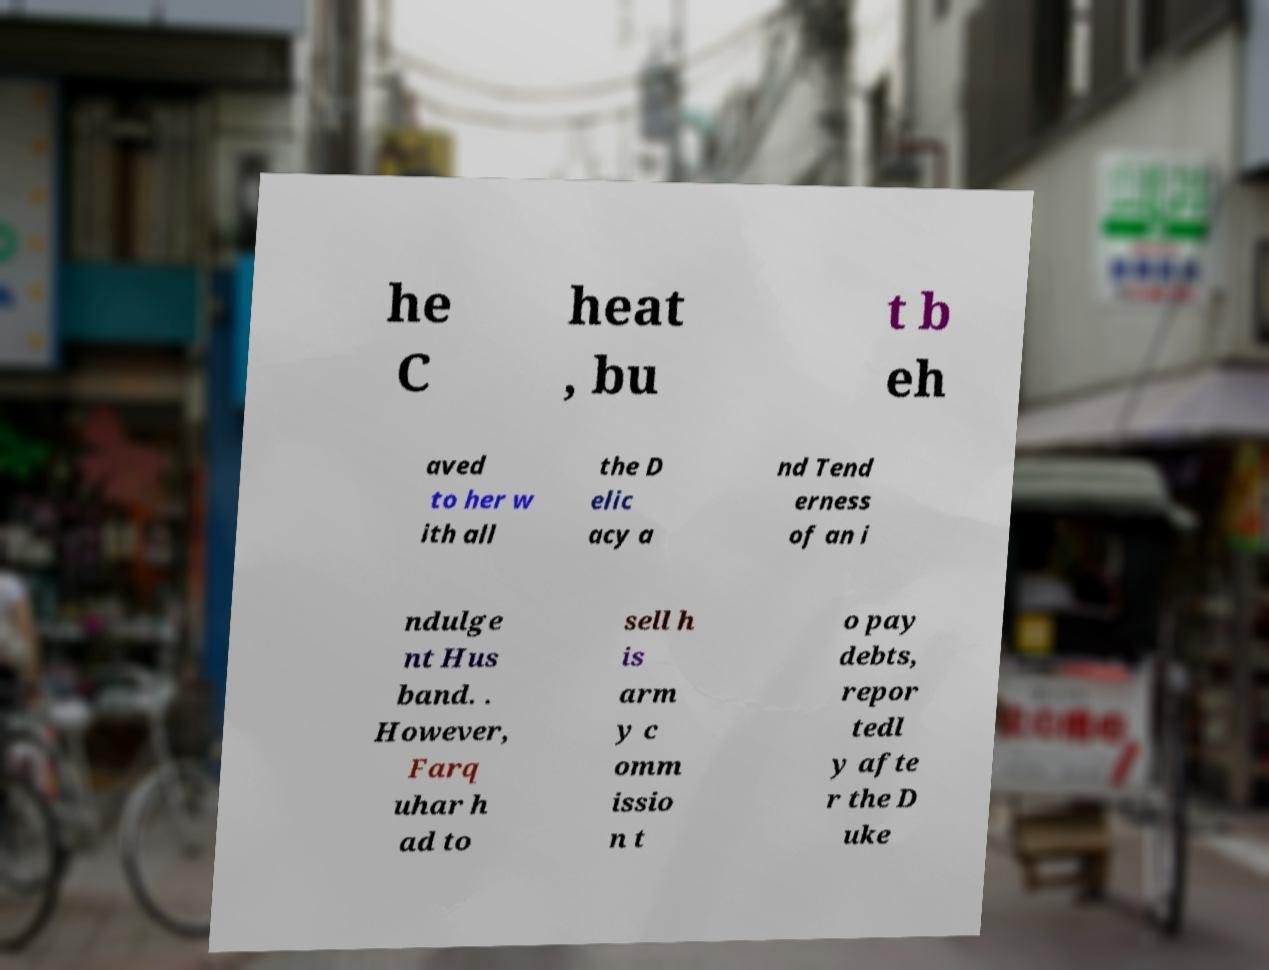Please read and relay the text visible in this image. What does it say? he C heat , bu t b eh aved to her w ith all the D elic acy a nd Tend erness of an i ndulge nt Hus band. . However, Farq uhar h ad to sell h is arm y c omm issio n t o pay debts, repor tedl y afte r the D uke 